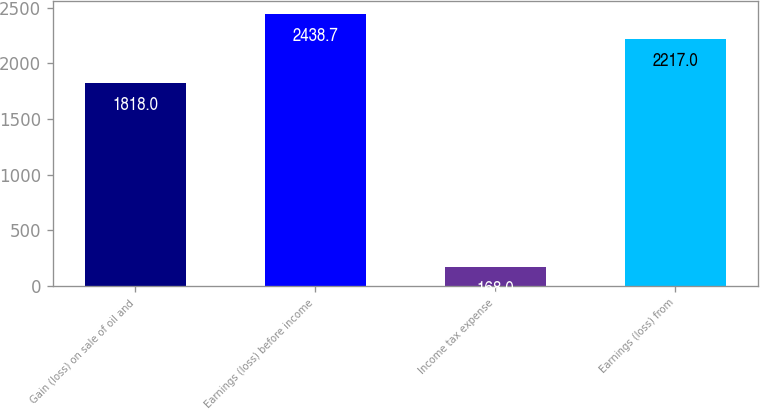<chart> <loc_0><loc_0><loc_500><loc_500><bar_chart><fcel>Gain (loss) on sale of oil and<fcel>Earnings (loss) before income<fcel>Income tax expense<fcel>Earnings (loss) from<nl><fcel>1818<fcel>2438.7<fcel>168<fcel>2217<nl></chart> 